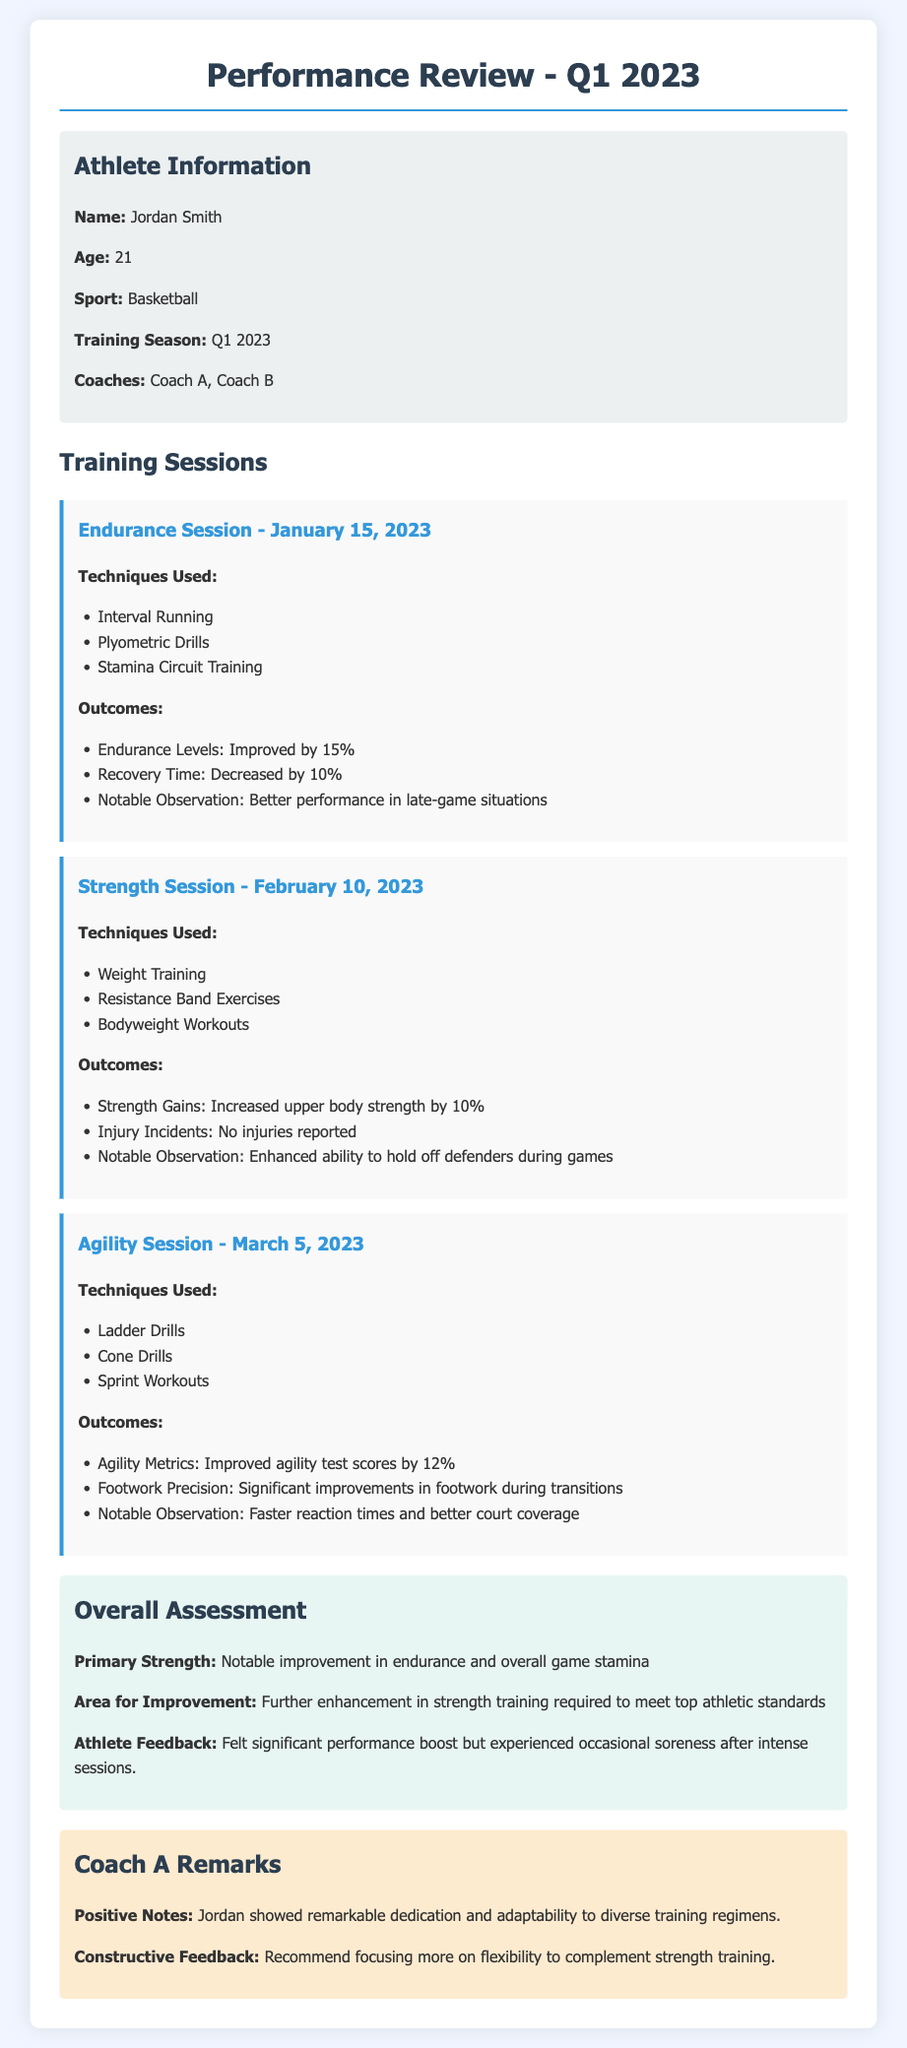What is the athlete's name? The athlete's name is stated in the "Athlete Information" section of the document.
Answer: Jordan Smith Which coach led the endurance session? The document details the training sessions under selected coaches, and the endurance session is listed under Coach A.
Answer: Coach A How much did endurance levels improve by? The percentage of improvement in endurance levels during the training sessions is detailed under the "Outcomes" section of the endurance session.
Answer: 15% What were the techniques used in the strength session? The techniques for the strength session can be found in the session description; specifically, they list the exercises used during that session.
Answer: Weight Training, Resistance Band Exercises, Bodyweight Workouts What is the primary strength mentioned in the overall assessment? The primary strength of the athlete is highlighted in the "Overall Assessment" section, summarizing the notable improvement noted by the coach.
Answer: Notable improvement in endurance and overall game stamina What was the notable observation from the agility session? The notable observation for improvements from the agility session is directly provided in the outcomes under that session's description.
Answer: Faster reaction times and better court coverage How much did agility test scores improve by? The improvement in agility test scores is detailed within the outcomes of the agility session in the document.
Answer: 12% What did Coach A recommend focusing on? Coach A's constructive feedback suggests an area of focus for the athlete, which is mentioned in the coach's remarks section.
Answer: Flexibility 